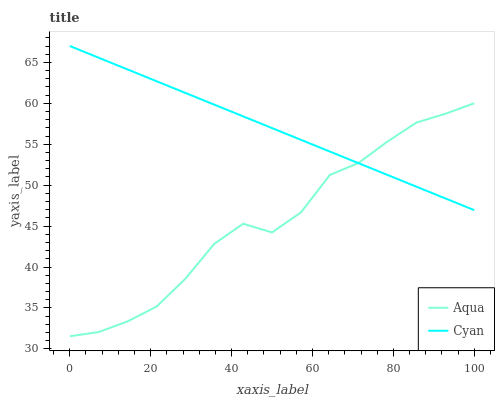Does Aqua have the maximum area under the curve?
Answer yes or no. No. Is Aqua the smoothest?
Answer yes or no. No. Does Aqua have the highest value?
Answer yes or no. No. 